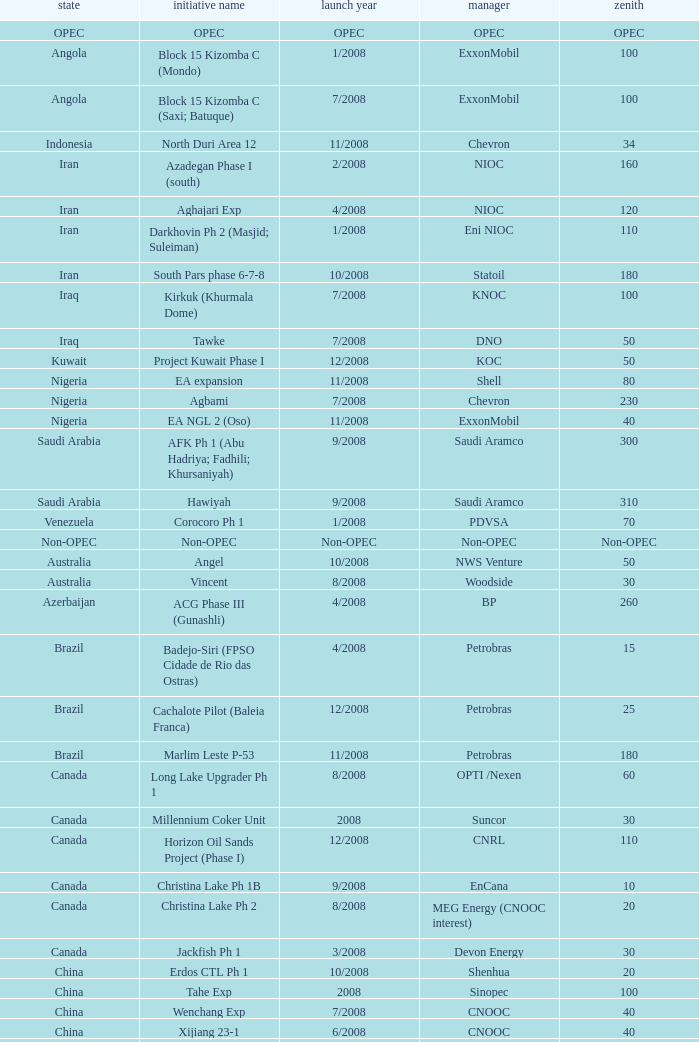What is the Project Name with a Country that is opec? OPEC. 